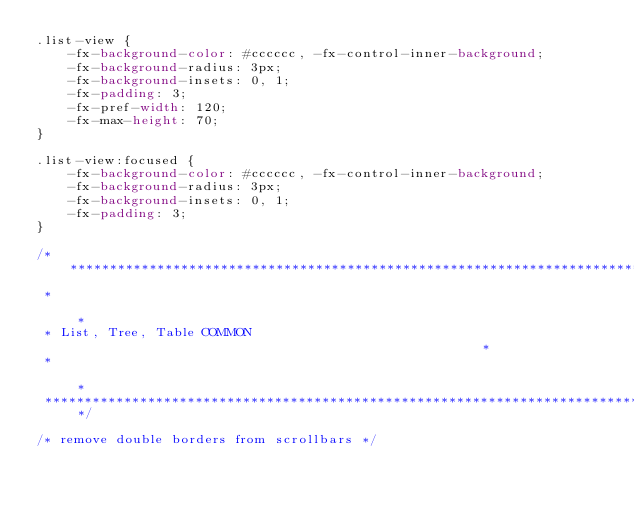Convert code to text. <code><loc_0><loc_0><loc_500><loc_500><_CSS_>.list-view {
    -fx-background-color: #cccccc, -fx-control-inner-background;
    -fx-background-radius: 3px;
    -fx-background-insets: 0, 1;
    -fx-padding: 3;
    -fx-pref-width: 120;
    -fx-max-height: 70;
}

.list-view:focused {
    -fx-background-color: #cccccc, -fx-control-inner-background;
    -fx-background-radius: 3px;
    -fx-background-insets: 0, 1;
    -fx-padding: 3;
}

/*******************************************************************************
 *                                                                             *
 * List, Tree, Table COMMON                                                    *
 *                                                                             *
 ******************************************************************************/

/* remove double borders from scrollbars */</code> 